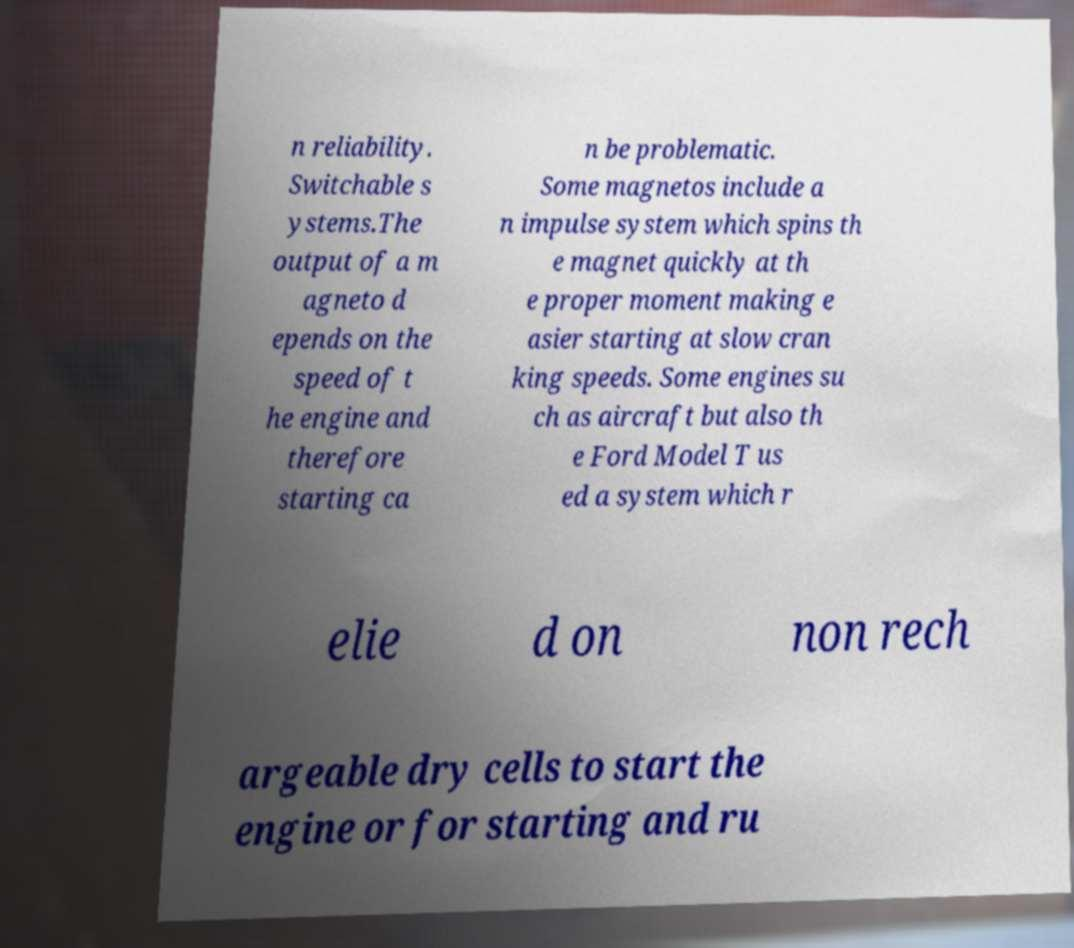Please read and relay the text visible in this image. What does it say? n reliability. Switchable s ystems.The output of a m agneto d epends on the speed of t he engine and therefore starting ca n be problematic. Some magnetos include a n impulse system which spins th e magnet quickly at th e proper moment making e asier starting at slow cran king speeds. Some engines su ch as aircraft but also th e Ford Model T us ed a system which r elie d on non rech argeable dry cells to start the engine or for starting and ru 